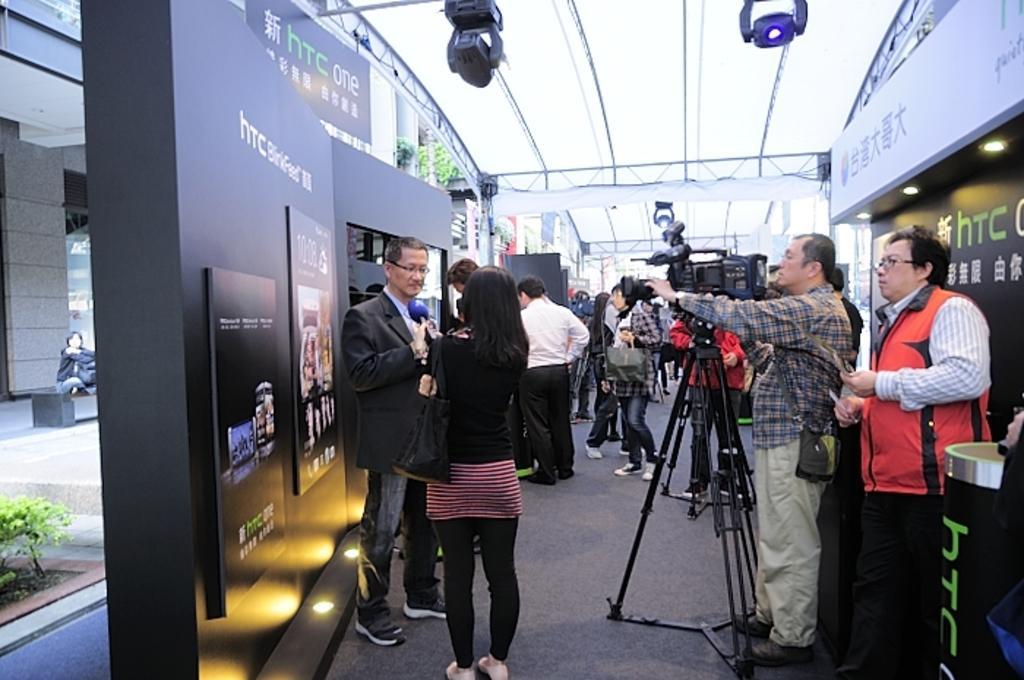Could you give a brief overview of what you see in this image? In this image we can see many people. There is a video camera on a stand. There is a lady holding a bag. Also there is a mic. And we can see photo frames on the wall. And there are images and text on the photo frames. Also there are walls with boards. On the boards there is text. On the left side there is a building. 